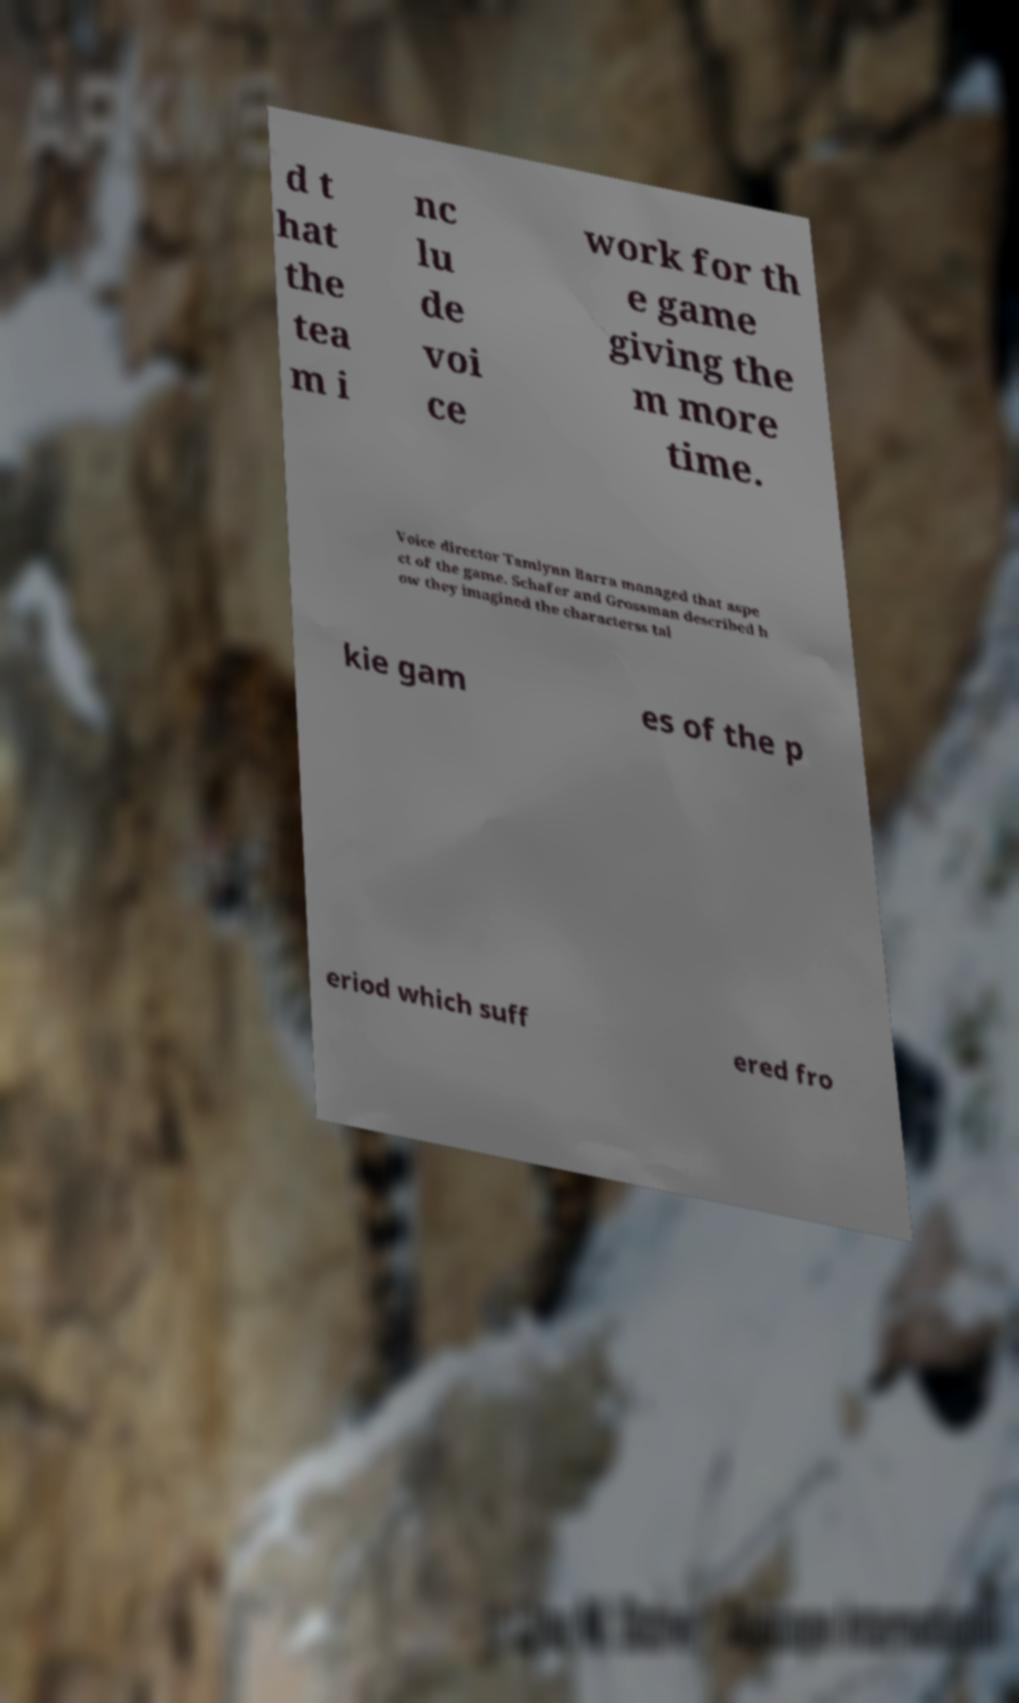There's text embedded in this image that I need extracted. Can you transcribe it verbatim? d t hat the tea m i nc lu de voi ce work for th e game giving the m more time. Voice director Tamlynn Barra managed that aspe ct of the game. Schafer and Grossman described h ow they imagined the characterss tal kie gam es of the p eriod which suff ered fro 